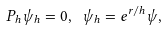Convert formula to latex. <formula><loc_0><loc_0><loc_500><loc_500>P _ { h } \psi _ { h } = 0 , \ \psi _ { h } = e ^ { r / h } \psi ,</formula> 